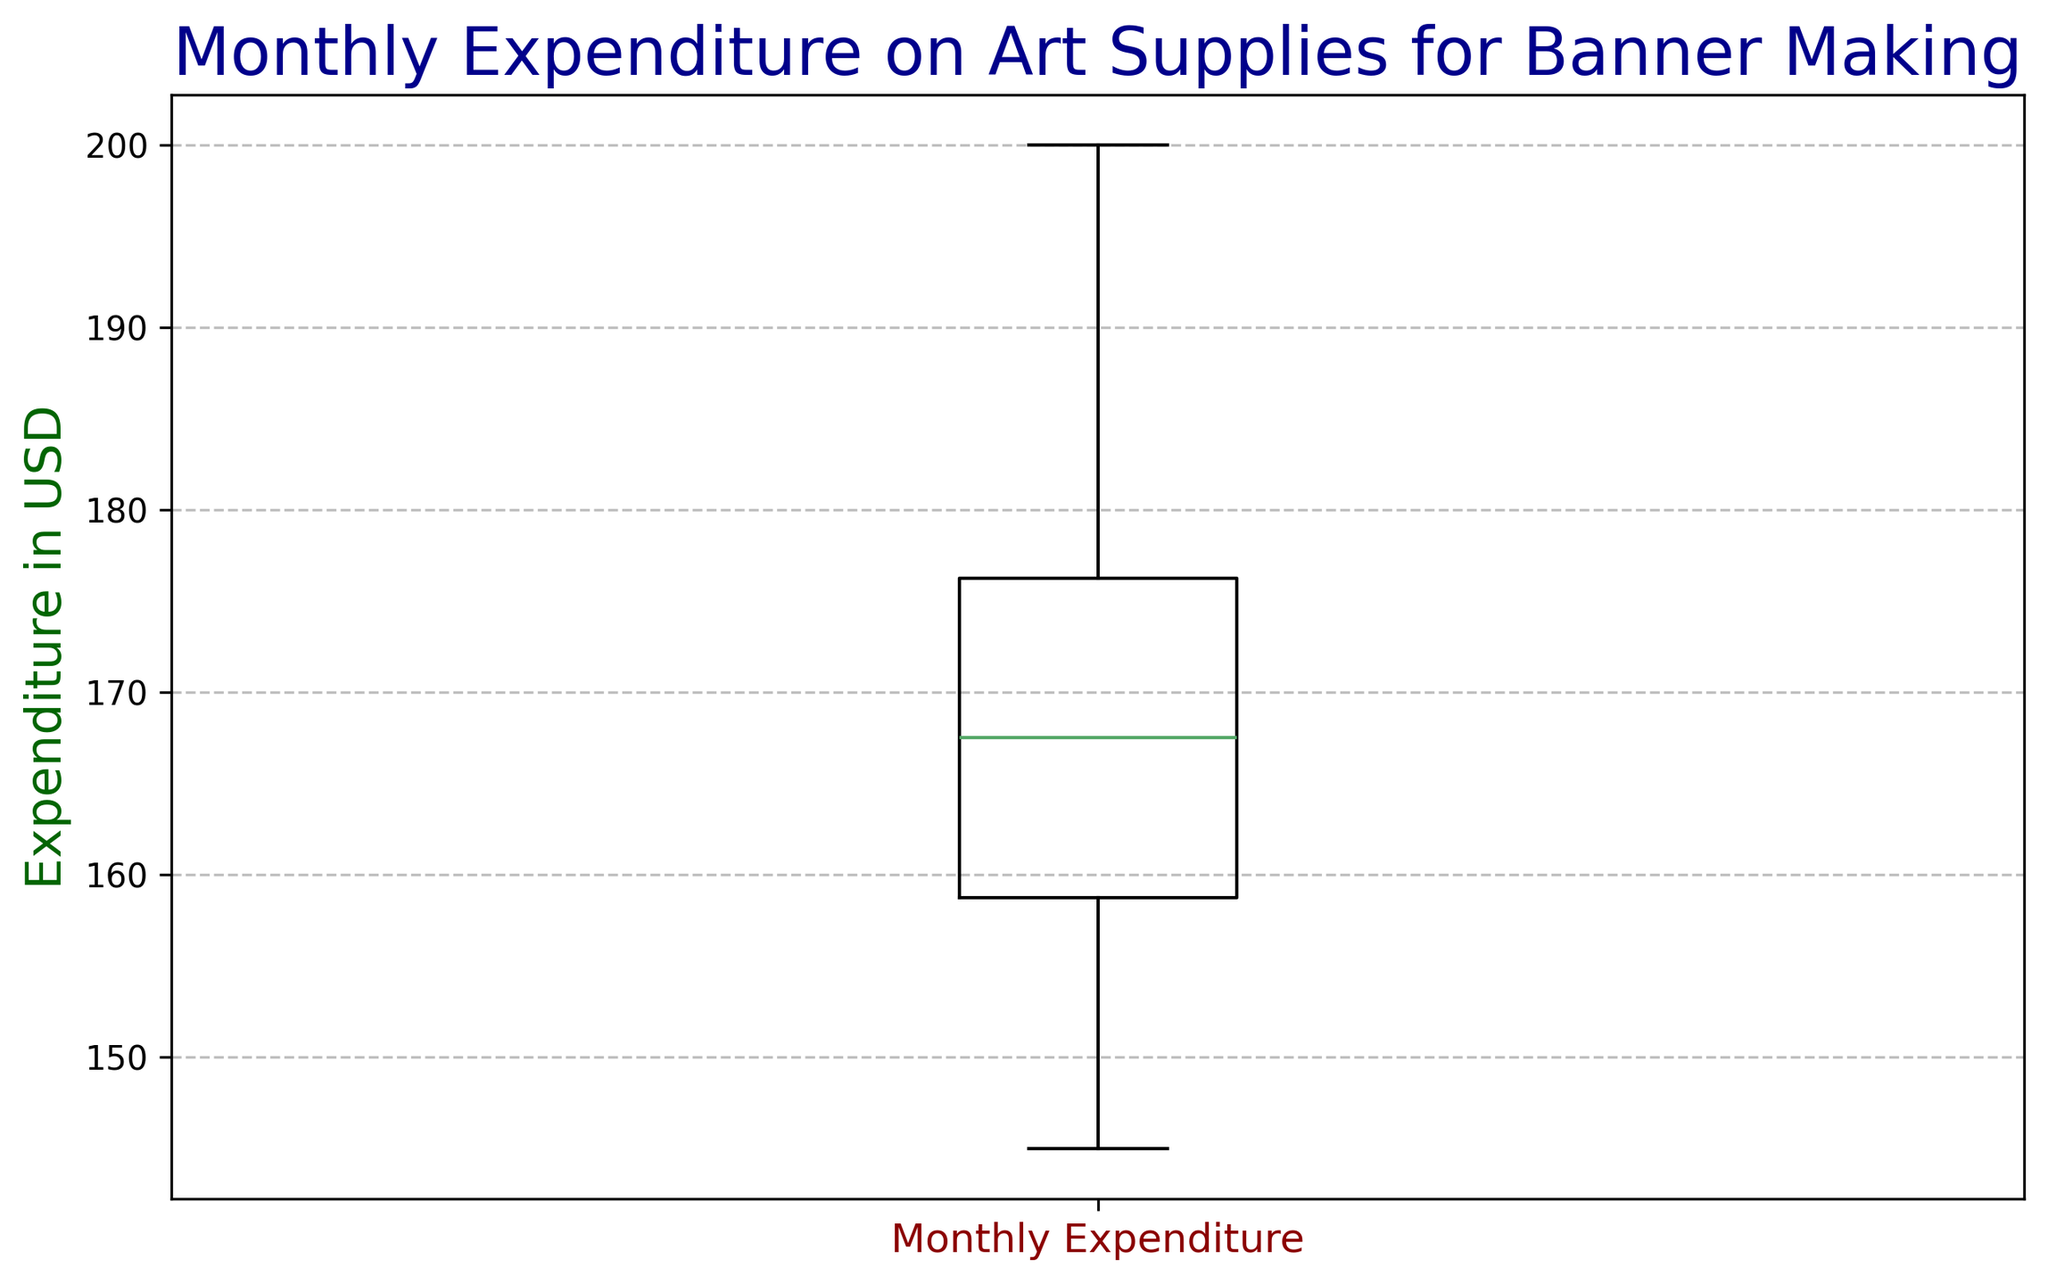What is the median monthly expenditure on art supplies for banner making? The median value of the expenditures is represented by the line inside the box on the box plot. This line appears at 165 USD.
Answer: 165 USD What is the range of monthly expenditures on art supplies for banner making? The range is the difference between the maximum and minimum values. The maximum value shown is 200 USD and the minimum is 145 USD. So, the range is 200 - 145 = 55 USD.
Answer: 55 USD Which month corresponds to the outlier expenditure, if any, based on the box plot? From the data used to generate the box plot, the highest expenditure is 200 USD. Box plots typically mark outliers with special symbols beyond the whiskers, but in this case, 200 USD is not marked as an outlier, so there are no outliers.
Answer: None What is the interquartile range (IQR) of the monthly expenditures? The interquartile range is the difference between the third quartile (Q3) and the first quartile (Q1). Q3 appears to be around 175 USD and Q1 around 155 USD. So, the IQR is 175 - 155 = 20 USD.
Answer: 20 USD What does the whisker at the high end of the box plot represent? The whisker at the high end of the box plot represents the maximum monthly expenditure that is not considered an outlier. According to the box plot, this value is 200 USD.
Answer: 200 USD How do the maximum and minimum expenditures compare? The maximum expenditure is 200 USD and the minimum expenditure is 145 USD. The maximum is larger by 55 USD.
Answer: 200 USD is larger by 55 USD Does the box plot indicate any outliers in the data? In the box plot, outliers are typically represented by points outside the whiskers. Since there are no points outside the whiskers, there are no outliers.
Answer: No How does the monthly expenditure distribution skew based on the box plot? The box plot appears to have a longer upper whisker than the lower whisker, indicating a possible right (positive) skew, suggesting more higher expenditures.
Answer: Right (positive) skew What is the general trend in the expenditure data based on the quartiles? The data is split into quartiles, with the middle 50% (the interquartile range) of the data between approximately 155 USD and 175 USD. This shows that most expenditures are in this range, with some higher expenditures up to 200 USD.
Answer: Middle 50% between 155 USD and 175 USD 